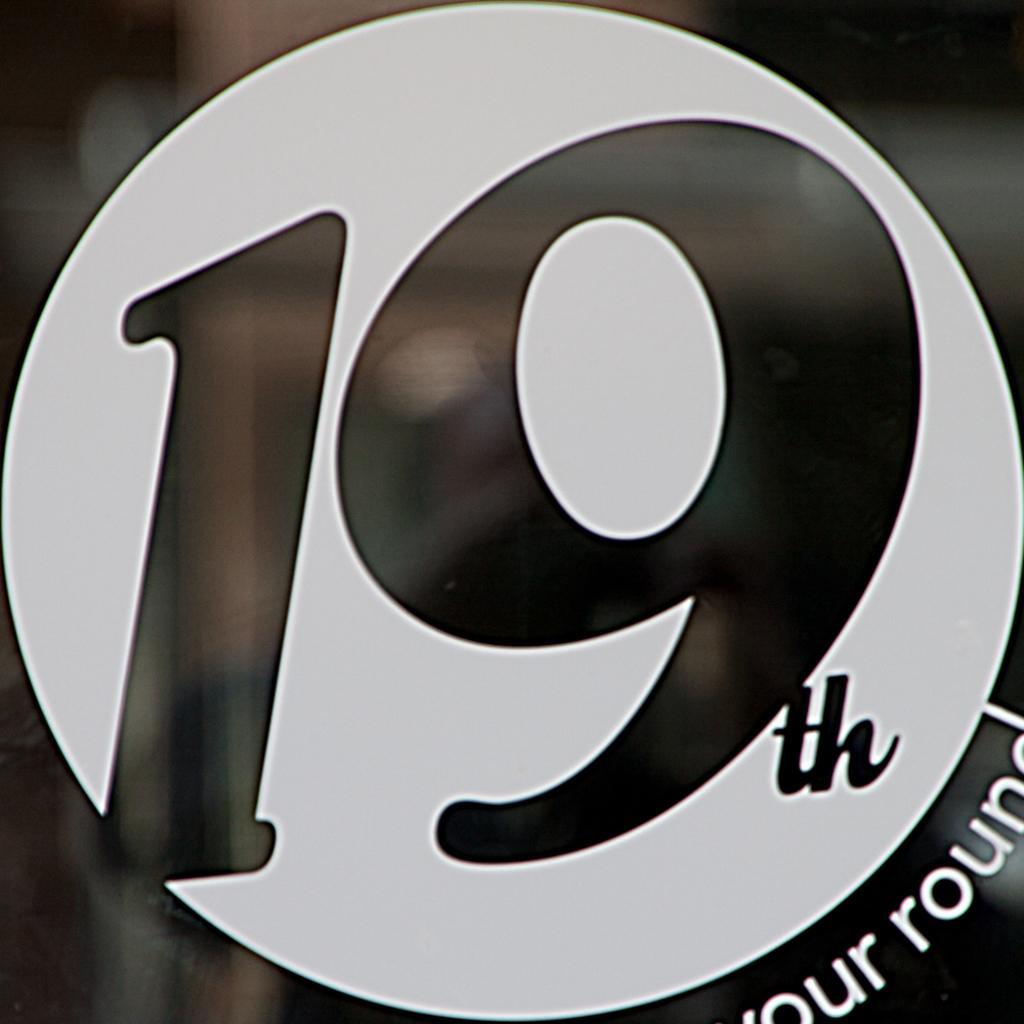Can you describe this image briefly? In this picture, we see a board or a poster in white and black color. We see 19 is written on it. We even see some text written on it. In the background, it is black in color. 